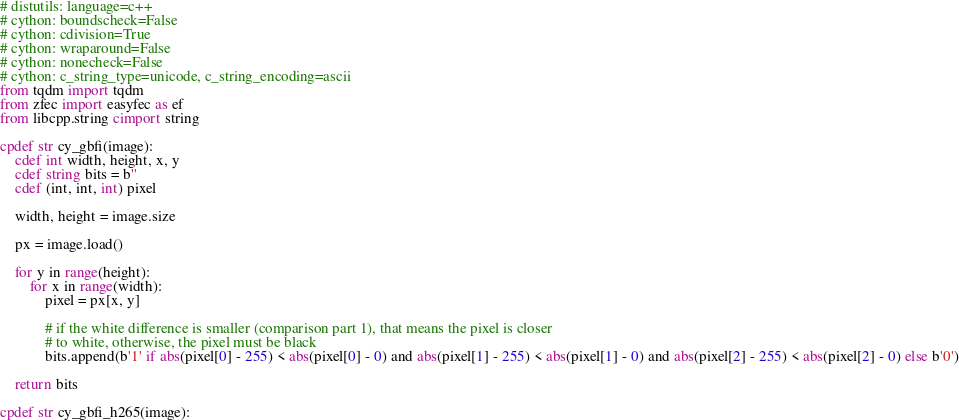Convert code to text. <code><loc_0><loc_0><loc_500><loc_500><_Cython_># distutils: language=c++
# cython: boundscheck=False
# cython: cdivision=True
# cython: wraparound=False
# cython: nonecheck=False
# cython: c_string_type=unicode, c_string_encoding=ascii
from tqdm import tqdm
from zfec import easyfec as ef
from libcpp.string cimport string

cpdef str cy_gbfi(image):
    cdef int width, height, x, y
    cdef string bits = b''
    cdef (int, int, int) pixel

    width, height = image.size

    px = image.load()
    
    for y in range(height):
        for x in range(width):
            pixel = px[x, y]

            # if the white difference is smaller (comparison part 1), that means the pixel is closer
            # to white, otherwise, the pixel must be black
            bits.append(b'1' if abs(pixel[0] - 255) < abs(pixel[0] - 0) and abs(pixel[1] - 255) < abs(pixel[1] - 0) and abs(pixel[2] - 255) < abs(pixel[2] - 0) else b'0')

    return bits

cpdef str cy_gbfi_h265(image):</code> 